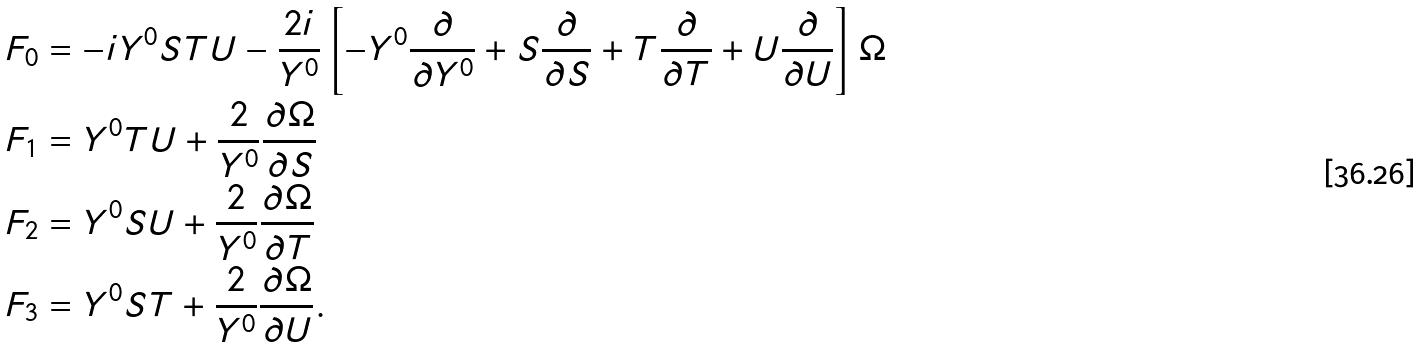Convert formula to latex. <formula><loc_0><loc_0><loc_500><loc_500>& F _ { 0 } = - i Y ^ { 0 } S T U - \frac { 2 i } { Y ^ { 0 } } \left [ - Y ^ { 0 } \frac { \partial } { \partial Y ^ { 0 } } + S \frac { \partial } { \partial S } + T \frac { \partial } { \partial T } + U \frac { \partial } { \partial U } \right ] \Omega \\ & F _ { 1 } = Y ^ { 0 } T U + \frac { 2 } { Y ^ { 0 } } \frac { \partial \Omega } { \partial S } \\ & F _ { 2 } = Y ^ { 0 } S U + \frac { 2 } { Y ^ { 0 } } \frac { \partial \Omega } { \partial T } \\ & F _ { 3 } = Y ^ { 0 } S T + \frac { 2 } { Y ^ { 0 } } \frac { \partial \Omega } { \partial U } . \\</formula> 